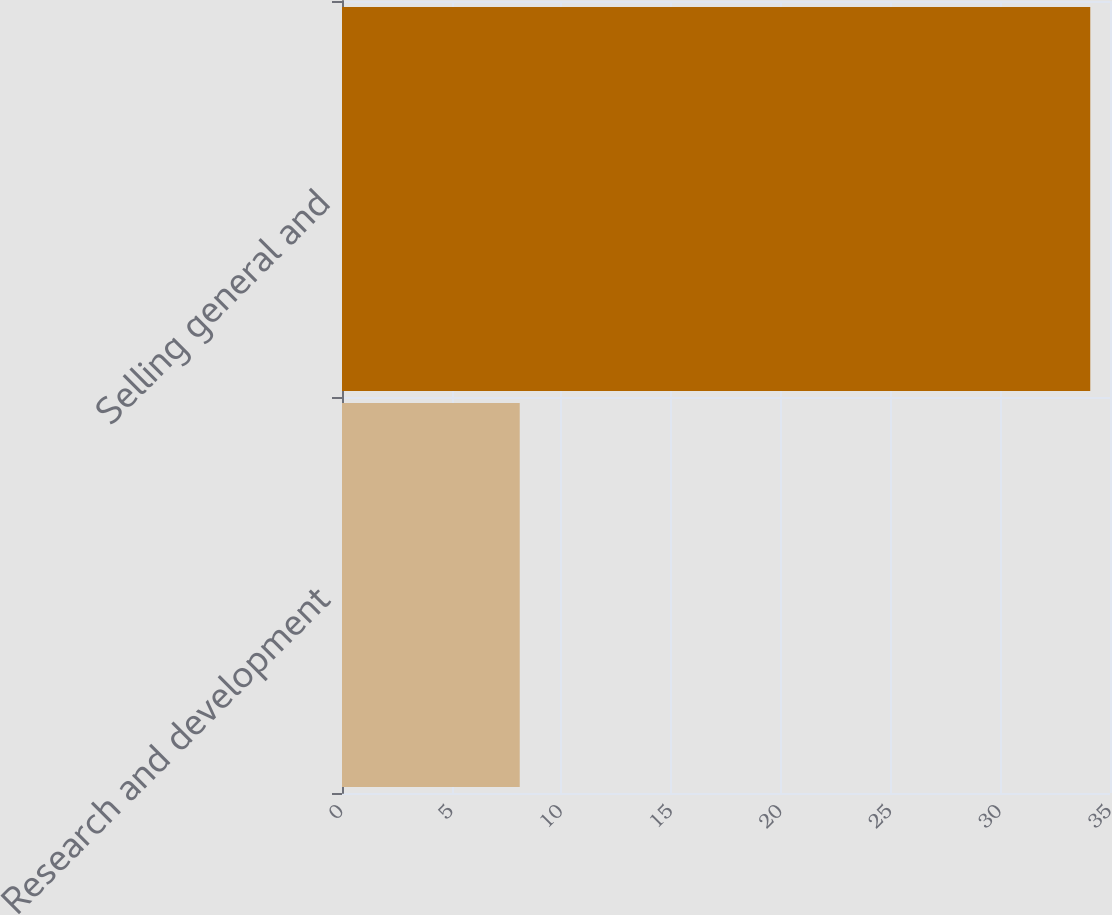Convert chart to OTSL. <chart><loc_0><loc_0><loc_500><loc_500><bar_chart><fcel>Research and development<fcel>Selling general and<nl><fcel>8.1<fcel>34.1<nl></chart> 